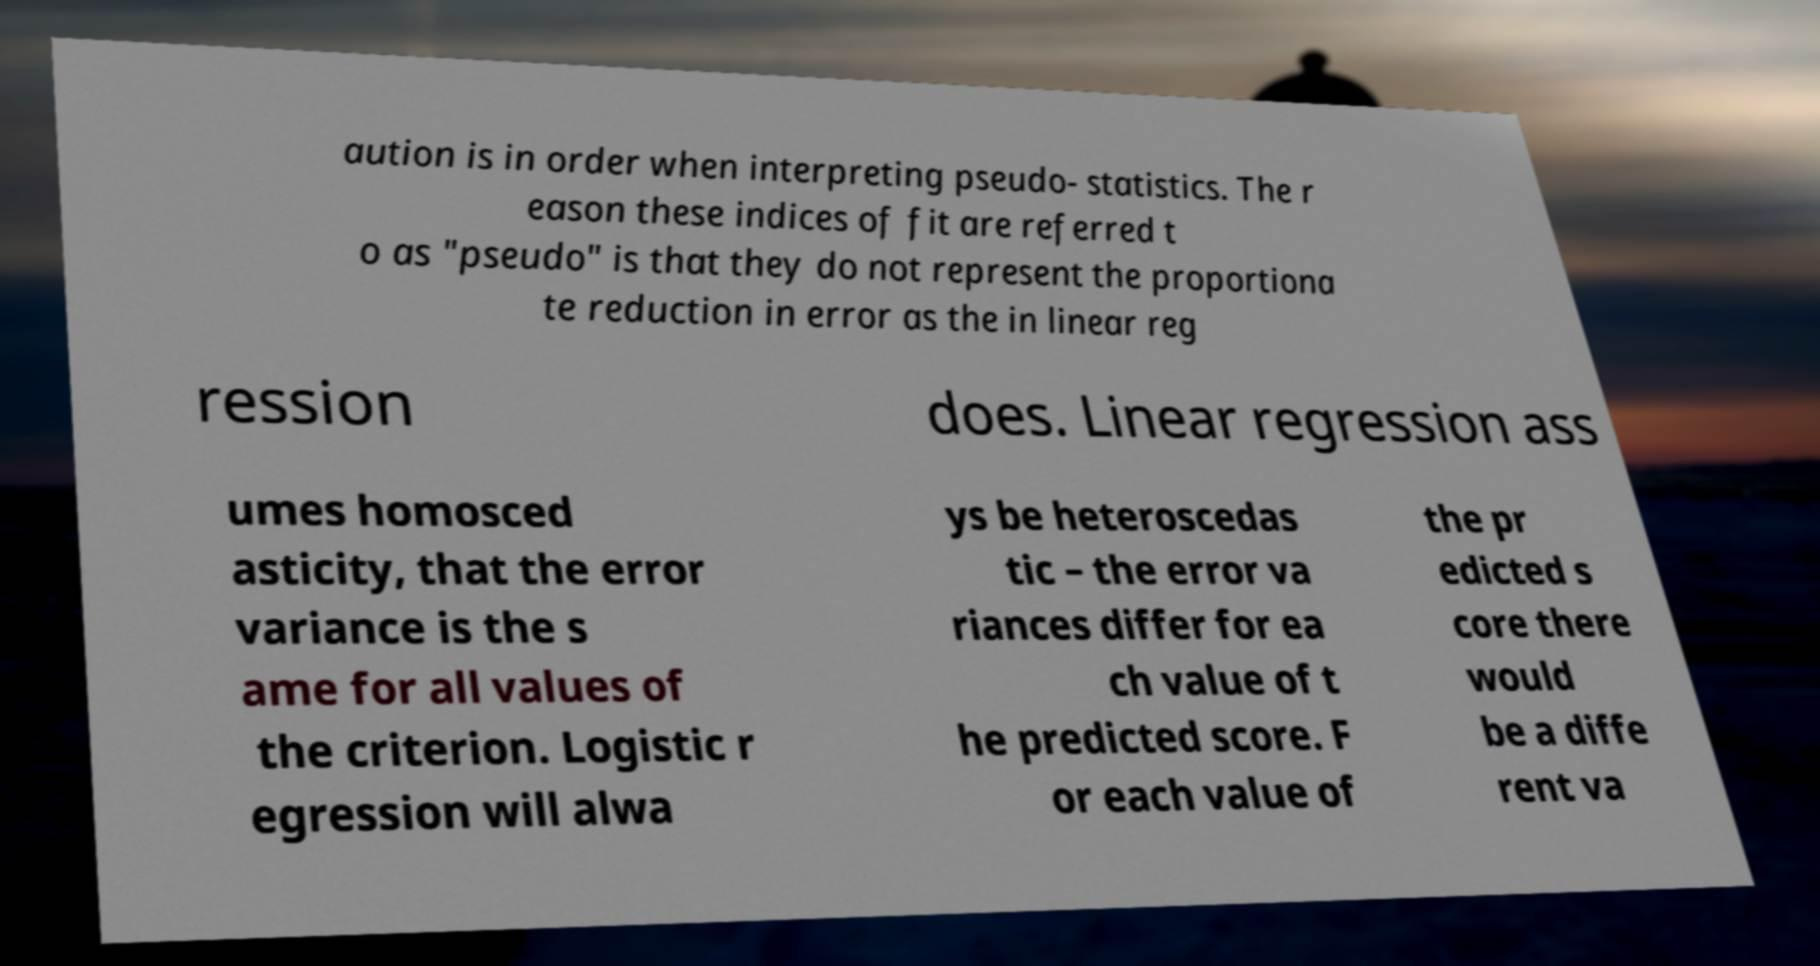Can you accurately transcribe the text from the provided image for me? aution is in order when interpreting pseudo- statistics. The r eason these indices of fit are referred t o as "pseudo" is that they do not represent the proportiona te reduction in error as the in linear reg ression does. Linear regression ass umes homosced asticity, that the error variance is the s ame for all values of the criterion. Logistic r egression will alwa ys be heteroscedas tic – the error va riances differ for ea ch value of t he predicted score. F or each value of the pr edicted s core there would be a diffe rent va 